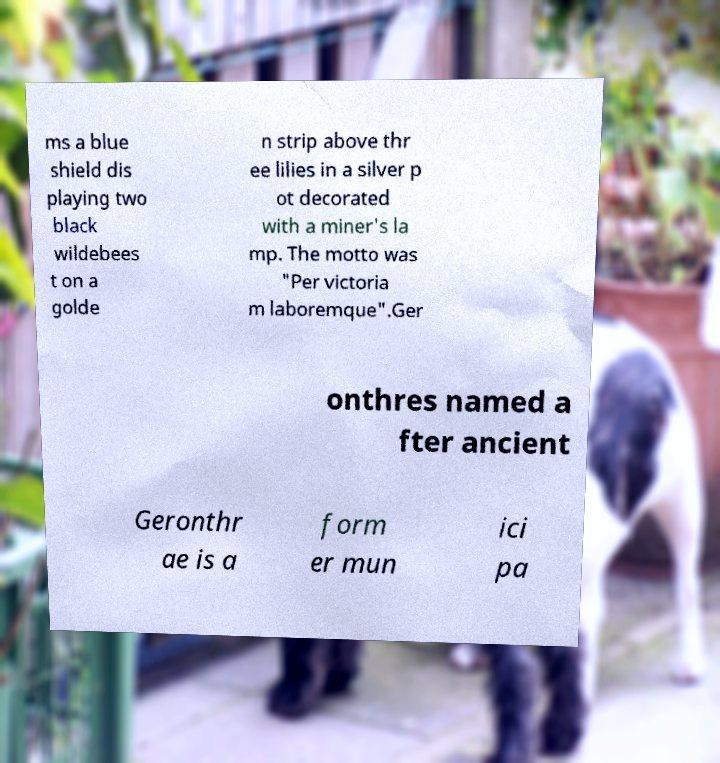Could you assist in decoding the text presented in this image and type it out clearly? ms a blue shield dis playing two black wildebees t on a golde n strip above thr ee lilies in a silver p ot decorated with a miner's la mp. The motto was "Per victoria m laboremque".Ger onthres named a fter ancient Geronthr ae is a form er mun ici pa 